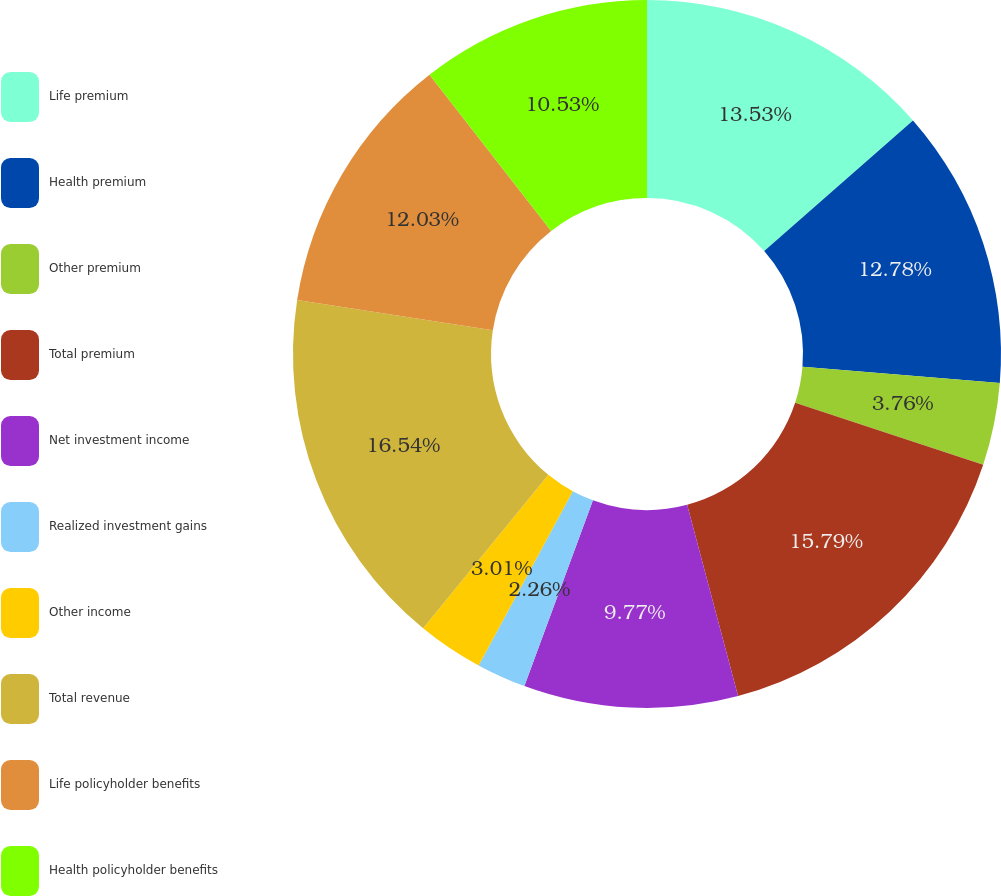<chart> <loc_0><loc_0><loc_500><loc_500><pie_chart><fcel>Life premium<fcel>Health premium<fcel>Other premium<fcel>Total premium<fcel>Net investment income<fcel>Realized investment gains<fcel>Other income<fcel>Total revenue<fcel>Life policyholder benefits<fcel>Health policyholder benefits<nl><fcel>13.53%<fcel>12.78%<fcel>3.76%<fcel>15.79%<fcel>9.77%<fcel>2.26%<fcel>3.01%<fcel>16.54%<fcel>12.03%<fcel>10.53%<nl></chart> 